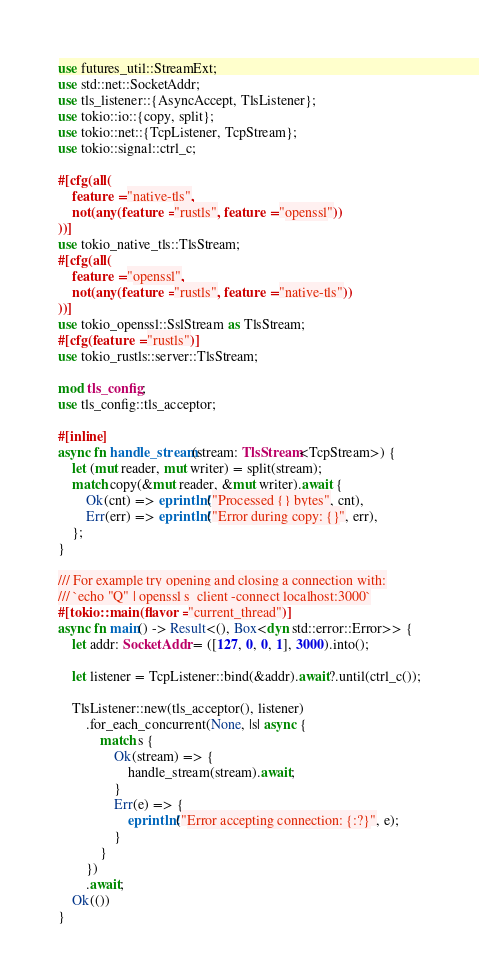Convert code to text. <code><loc_0><loc_0><loc_500><loc_500><_Rust_>use futures_util::StreamExt;
use std::net::SocketAddr;
use tls_listener::{AsyncAccept, TlsListener};
use tokio::io::{copy, split};
use tokio::net::{TcpListener, TcpStream};
use tokio::signal::ctrl_c;

#[cfg(all(
    feature = "native-tls",
    not(any(feature = "rustls", feature = "openssl"))
))]
use tokio_native_tls::TlsStream;
#[cfg(all(
    feature = "openssl",
    not(any(feature = "rustls", feature = "native-tls"))
))]
use tokio_openssl::SslStream as TlsStream;
#[cfg(feature = "rustls")]
use tokio_rustls::server::TlsStream;

mod tls_config;
use tls_config::tls_acceptor;

#[inline]
async fn handle_stream(stream: TlsStream<TcpStream>) {
    let (mut reader, mut writer) = split(stream);
    match copy(&mut reader, &mut writer).await {
        Ok(cnt) => eprintln!("Processed {} bytes", cnt),
        Err(err) => eprintln!("Error during copy: {}", err),
    };
}

/// For example try opening and closing a connection with:
/// `echo "Q" | openssl s_client -connect localhost:3000`
#[tokio::main(flavor = "current_thread")]
async fn main() -> Result<(), Box<dyn std::error::Error>> {
    let addr: SocketAddr = ([127, 0, 0, 1], 3000).into();

    let listener = TcpListener::bind(&addr).await?.until(ctrl_c());

    TlsListener::new(tls_acceptor(), listener)
        .for_each_concurrent(None, |s| async {
            match s {
                Ok(stream) => {
                    handle_stream(stream).await;
                }
                Err(e) => {
                    eprintln!("Error accepting connection: {:?}", e);
                }
            }
        })
        .await;
    Ok(())
}
</code> 